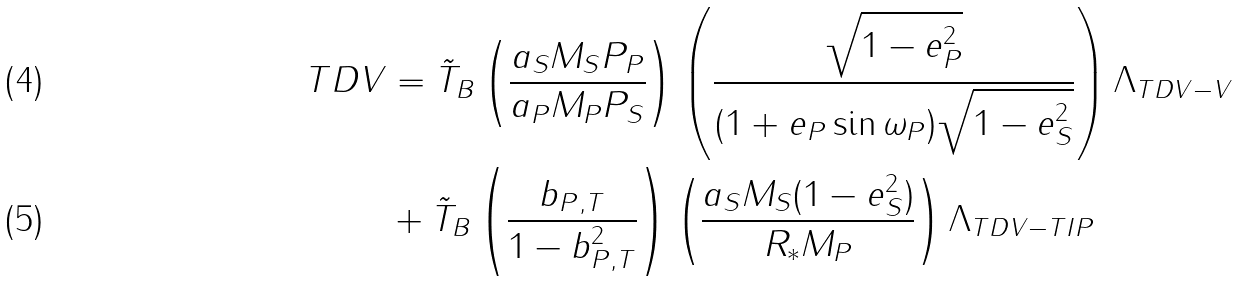Convert formula to latex. <formula><loc_0><loc_0><loc_500><loc_500>T D V & = \tilde { T } _ { B } \left ( \frac { a _ { S } M _ { S } P _ { P } } { a _ { P } M _ { P } P _ { S } } \right ) \left ( \frac { \sqrt { 1 - e _ { P } ^ { 2 } } } { ( 1 + e _ { P } \sin \omega _ { P } ) \sqrt { 1 - e _ { S } ^ { 2 } } } \right ) \Lambda _ { T D V - V } \\ \quad & + \tilde { T } _ { B } \left ( \frac { b _ { P , T } } { 1 - b _ { P , T } ^ { 2 } } \right ) \left ( \frac { a _ { S } M _ { S } ( 1 - e _ { S } ^ { 2 } ) } { R _ { * } M _ { P } } \right ) \Lambda _ { T D V - T I P }</formula> 